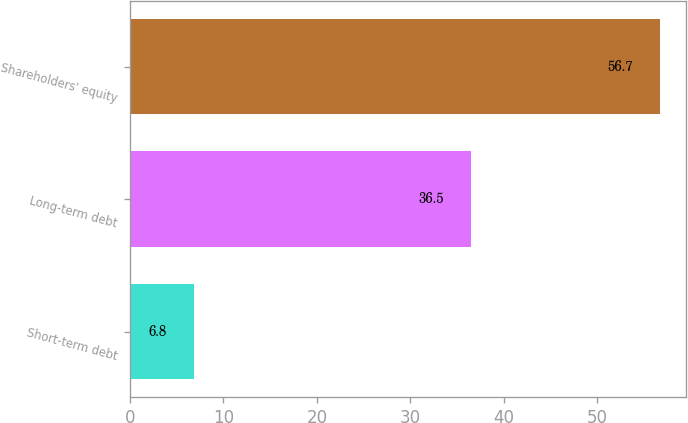<chart> <loc_0><loc_0><loc_500><loc_500><bar_chart><fcel>Short-term debt<fcel>Long-term debt<fcel>Shareholders' equity<nl><fcel>6.8<fcel>36.5<fcel>56.7<nl></chart> 